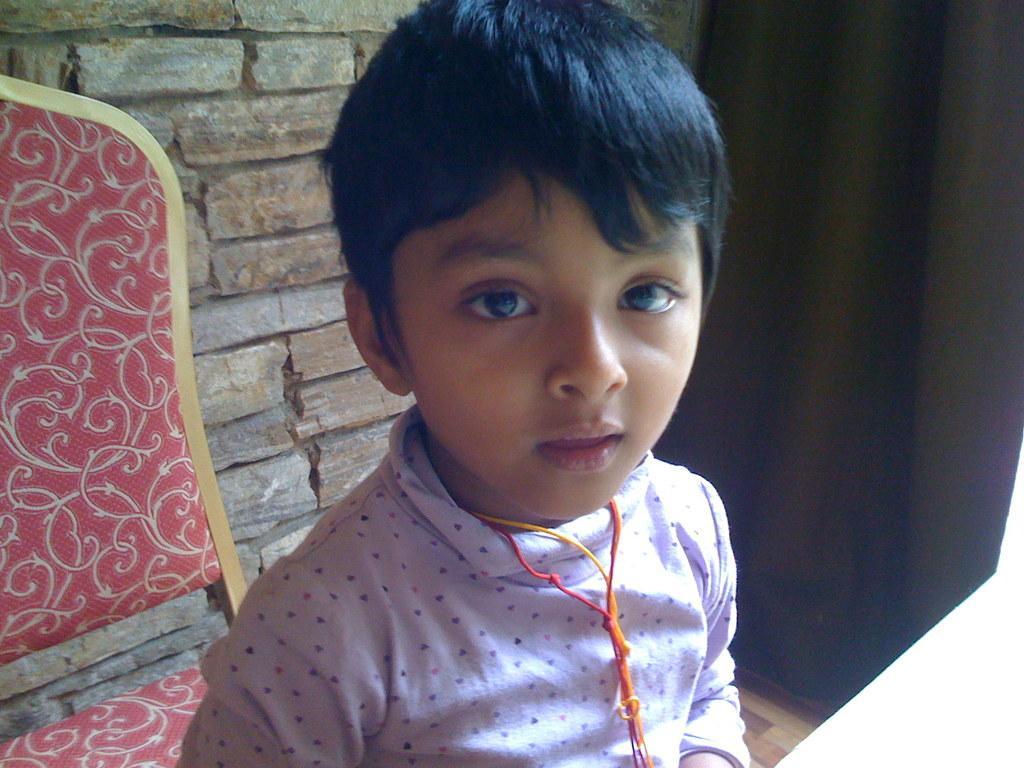Can you describe this image briefly? In this image in the foreground there is one boy, and in the background there is a chair, wall. And on the right side there is a curtain, at the bottom there is floor. 